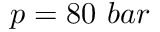<formula> <loc_0><loc_0><loc_500><loc_500>p = 8 0 \ b a r</formula> 